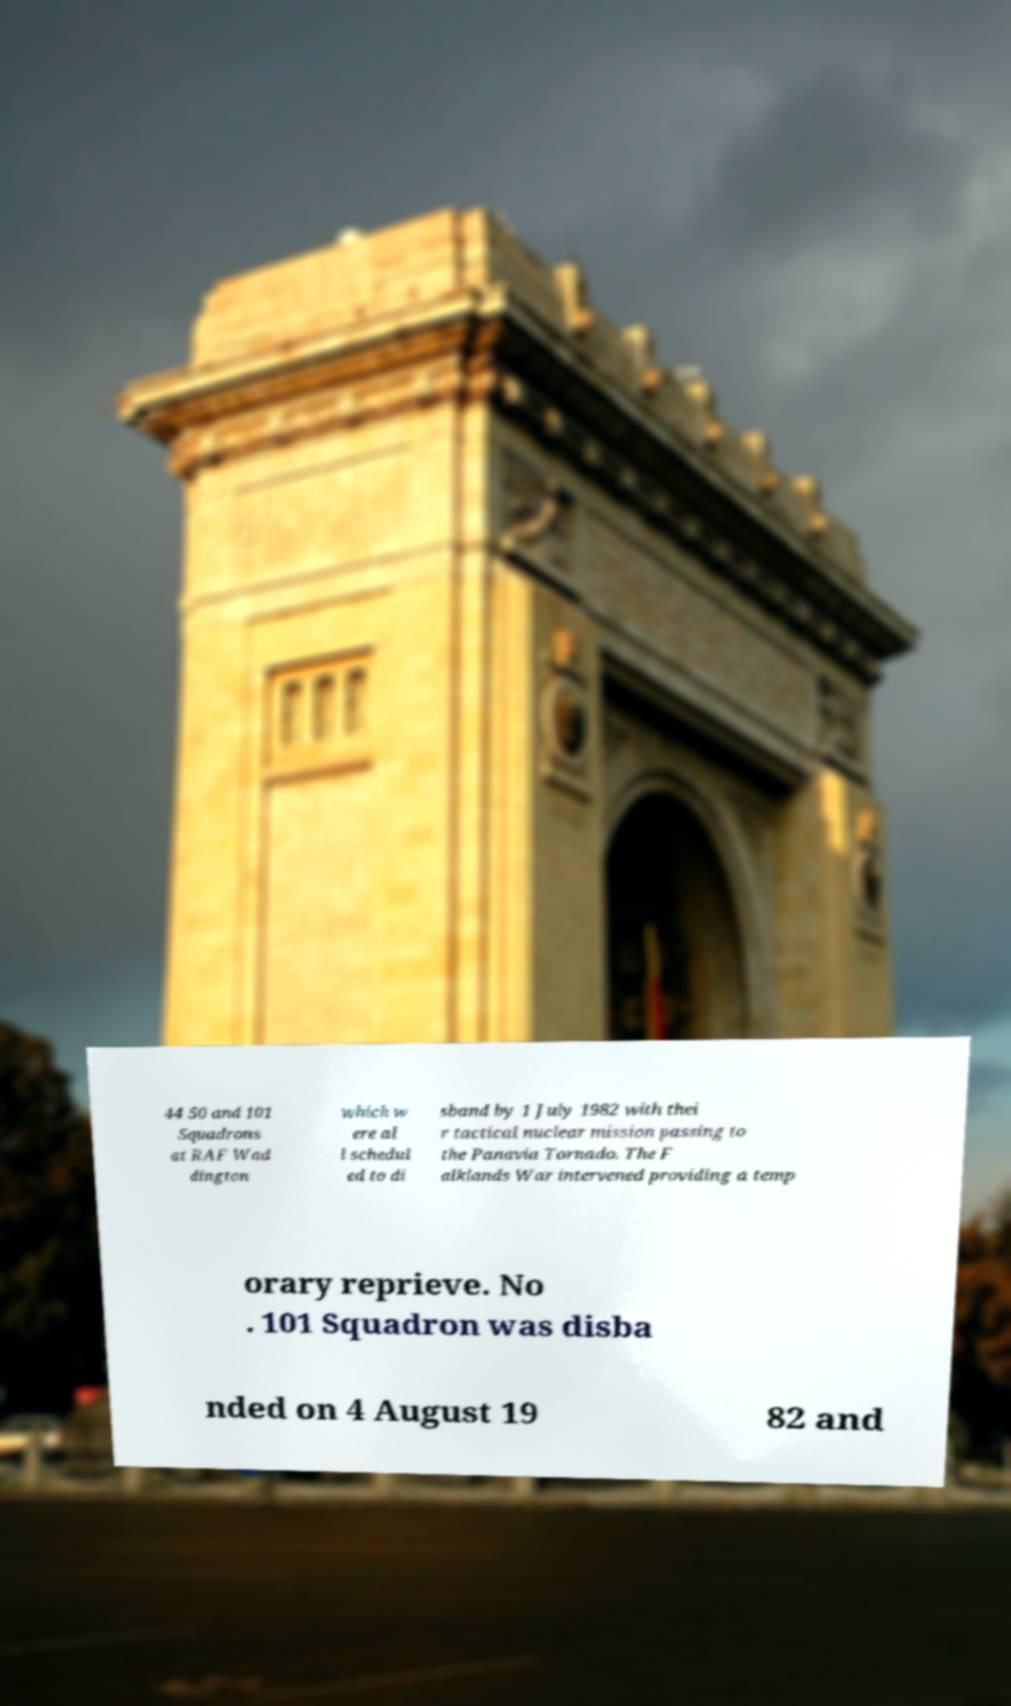What messages or text are displayed in this image? I need them in a readable, typed format. 44 50 and 101 Squadrons at RAF Wad dington which w ere al l schedul ed to di sband by 1 July 1982 with thei r tactical nuclear mission passing to the Panavia Tornado. The F alklands War intervened providing a temp orary reprieve. No . 101 Squadron was disba nded on 4 August 19 82 and 